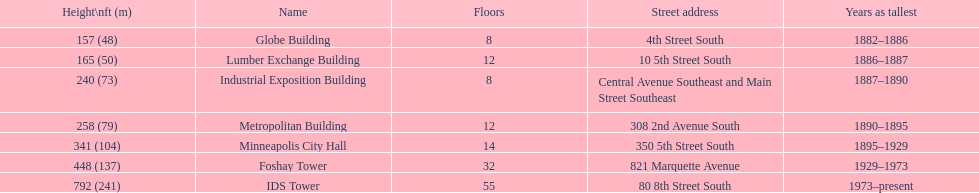What was the first building named as the tallest? Globe Building. 